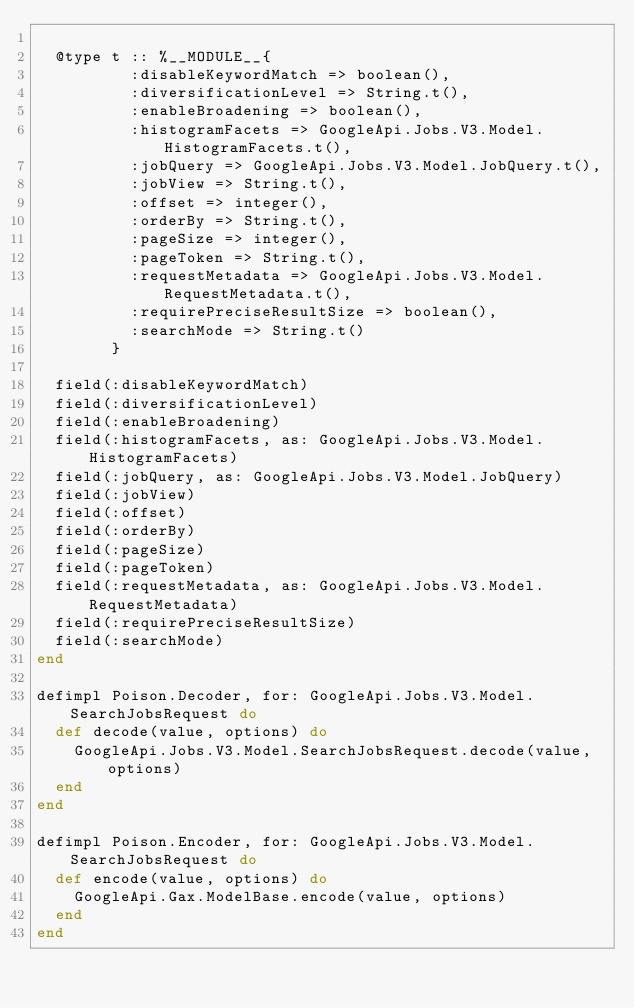Convert code to text. <code><loc_0><loc_0><loc_500><loc_500><_Elixir_>
  @type t :: %__MODULE__{
          :disableKeywordMatch => boolean(),
          :diversificationLevel => String.t(),
          :enableBroadening => boolean(),
          :histogramFacets => GoogleApi.Jobs.V3.Model.HistogramFacets.t(),
          :jobQuery => GoogleApi.Jobs.V3.Model.JobQuery.t(),
          :jobView => String.t(),
          :offset => integer(),
          :orderBy => String.t(),
          :pageSize => integer(),
          :pageToken => String.t(),
          :requestMetadata => GoogleApi.Jobs.V3.Model.RequestMetadata.t(),
          :requirePreciseResultSize => boolean(),
          :searchMode => String.t()
        }

  field(:disableKeywordMatch)
  field(:diversificationLevel)
  field(:enableBroadening)
  field(:histogramFacets, as: GoogleApi.Jobs.V3.Model.HistogramFacets)
  field(:jobQuery, as: GoogleApi.Jobs.V3.Model.JobQuery)
  field(:jobView)
  field(:offset)
  field(:orderBy)
  field(:pageSize)
  field(:pageToken)
  field(:requestMetadata, as: GoogleApi.Jobs.V3.Model.RequestMetadata)
  field(:requirePreciseResultSize)
  field(:searchMode)
end

defimpl Poison.Decoder, for: GoogleApi.Jobs.V3.Model.SearchJobsRequest do
  def decode(value, options) do
    GoogleApi.Jobs.V3.Model.SearchJobsRequest.decode(value, options)
  end
end

defimpl Poison.Encoder, for: GoogleApi.Jobs.V3.Model.SearchJobsRequest do
  def encode(value, options) do
    GoogleApi.Gax.ModelBase.encode(value, options)
  end
end
</code> 